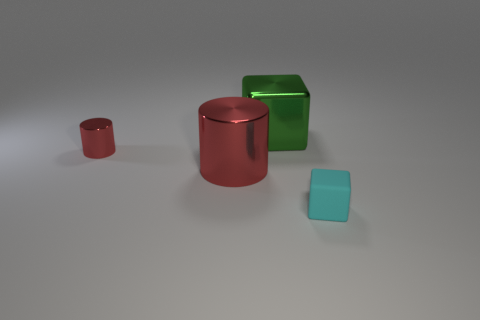Add 2 tiny red metal things. How many objects exist? 6 Add 4 big green cubes. How many big green cubes are left? 5 Add 1 small brown matte cubes. How many small brown matte cubes exist? 1 Subtract 0 brown blocks. How many objects are left? 4 Subtract all red things. Subtract all red shiny objects. How many objects are left? 0 